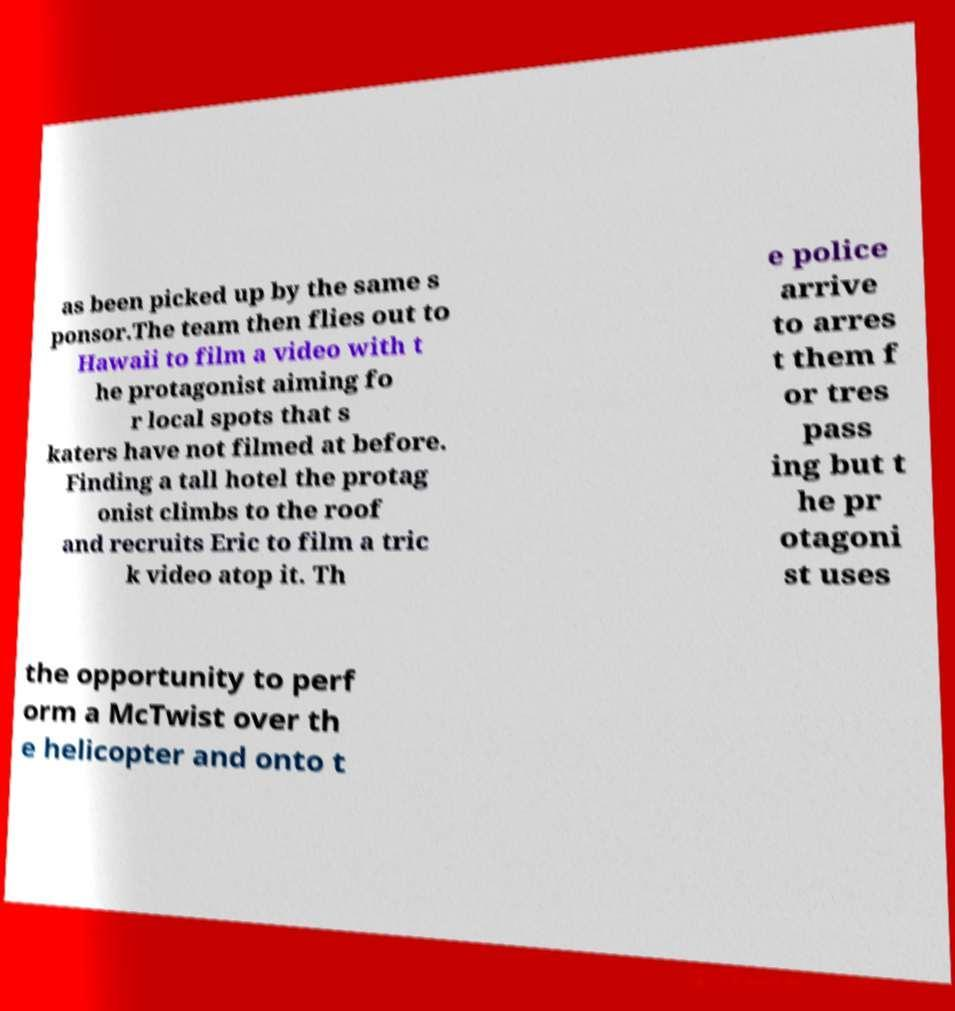Could you assist in decoding the text presented in this image and type it out clearly? as been picked up by the same s ponsor.The team then flies out to Hawaii to film a video with t he protagonist aiming fo r local spots that s katers have not filmed at before. Finding a tall hotel the protag onist climbs to the roof and recruits Eric to film a tric k video atop it. Th e police arrive to arres t them f or tres pass ing but t he pr otagoni st uses the opportunity to perf orm a McTwist over th e helicopter and onto t 